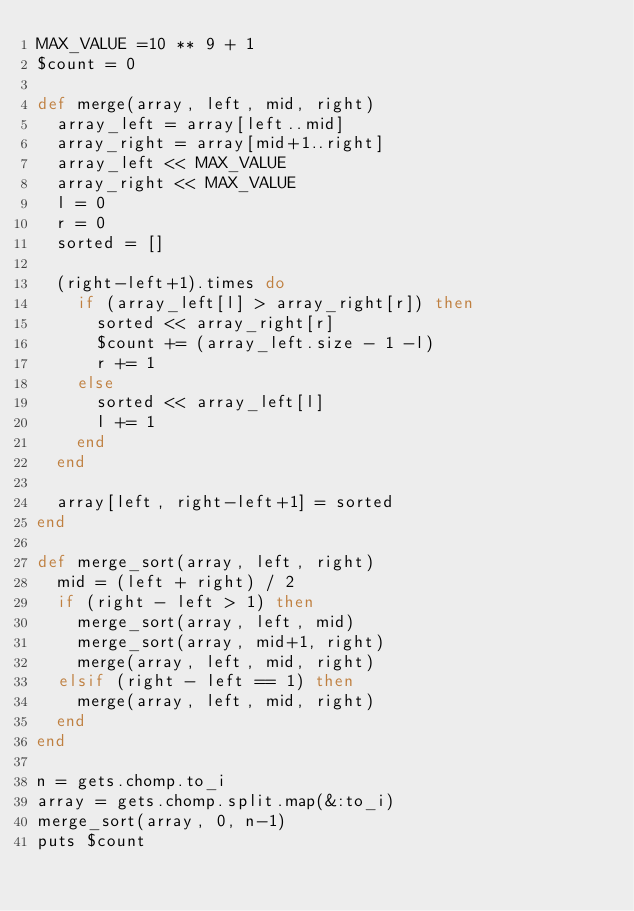<code> <loc_0><loc_0><loc_500><loc_500><_Ruby_>MAX_VALUE =10 ** 9 + 1
$count = 0

def merge(array, left, mid, right)
  array_left = array[left..mid]
  array_right = array[mid+1..right]
  array_left << MAX_VALUE
  array_right << MAX_VALUE
  l = 0
  r = 0
  sorted = []

  (right-left+1).times do 
    if (array_left[l] > array_right[r]) then
      sorted << array_right[r]
      $count += (array_left.size - 1 -l)
      r += 1
    else
      sorted << array_left[l]
      l += 1
    end
  end

  array[left, right-left+1] = sorted
end

def merge_sort(array, left, right)
  mid = (left + right) / 2
  if (right - left > 1) then
    merge_sort(array, left, mid)
    merge_sort(array, mid+1, right)
    merge(array, left, mid, right)
  elsif (right - left == 1) then
    merge(array, left, mid, right)
  end
end

n = gets.chomp.to_i
array = gets.chomp.split.map(&:to_i)
merge_sort(array, 0, n-1)
puts $count</code> 